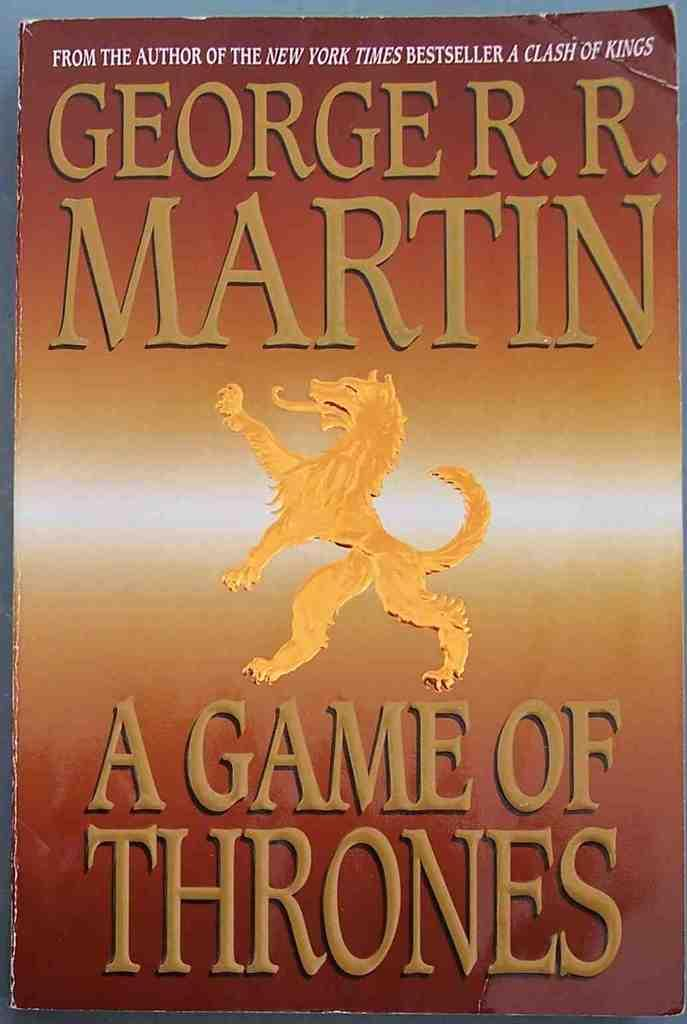Provide a one-sentence caption for the provided image. George R. R. Martin is the author of "A Game of Thrones". 